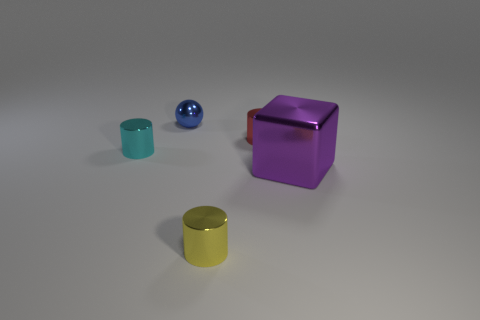How many objects are in front of the big block and to the right of the yellow object?
Make the answer very short. 0. What is the material of the red cylinder?
Give a very brief answer. Metal. Are there an equal number of blue things right of the red cylinder and big matte objects?
Provide a short and direct response. Yes. How many red shiny objects are the same shape as the yellow metal object?
Provide a short and direct response. 1. Is the tiny red shiny thing the same shape as the small cyan shiny thing?
Your response must be concise. Yes. What number of objects are either shiny things that are on the left side of the yellow thing or yellow metallic cylinders?
Offer a terse response. 3. The metal object that is on the left side of the small shiny object that is behind the metal cylinder that is behind the tiny cyan shiny cylinder is what shape?
Your response must be concise. Cylinder. There is a small yellow object that is made of the same material as the big block; what shape is it?
Provide a short and direct response. Cylinder. What is the size of the purple thing?
Your answer should be very brief. Large. Is the metal block the same size as the red shiny cylinder?
Provide a succinct answer. No. 